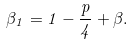Convert formula to latex. <formula><loc_0><loc_0><loc_500><loc_500>\beta _ { 1 } = 1 - \frac { p } { 4 } + \beta .</formula> 